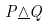<formula> <loc_0><loc_0><loc_500><loc_500>P \underline { \wedge } Q</formula> 